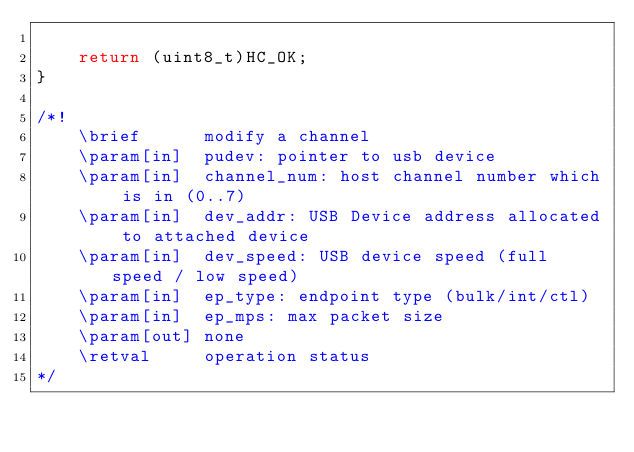Convert code to text. <code><loc_0><loc_0><loc_500><loc_500><_C_>
    return (uint8_t)HC_OK;
}

/*!
    \brief      modify a channel
    \param[in]  pudev: pointer to usb device
    \param[in]  channel_num: host channel number which is in (0..7)
    \param[in]  dev_addr: USB Device address allocated to attached device
    \param[in]  dev_speed: USB device speed (full speed / low speed)
    \param[in]  ep_type: endpoint type (bulk/int/ctl)
    \param[in]  ep_mps: max packet size
    \param[out] none
    \retval     operation status
*/</code> 